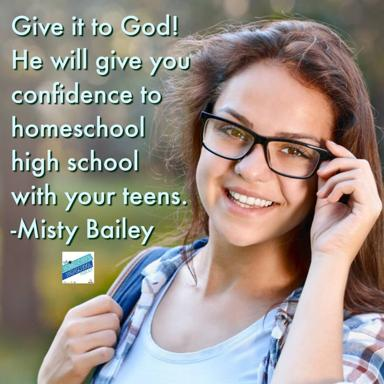What does Misty Bailey suggest in the image? In the image, Misty Bailey emphasizes the power of entrusting your fears and doubts to a higher power, in this case, God, in order to gain confidence and peace while educating your high school-aged teens at home. She suggests that this spiritual surrender can lead to greater resolve and clarity in the challenging but rewarding journey of homeschooling. 